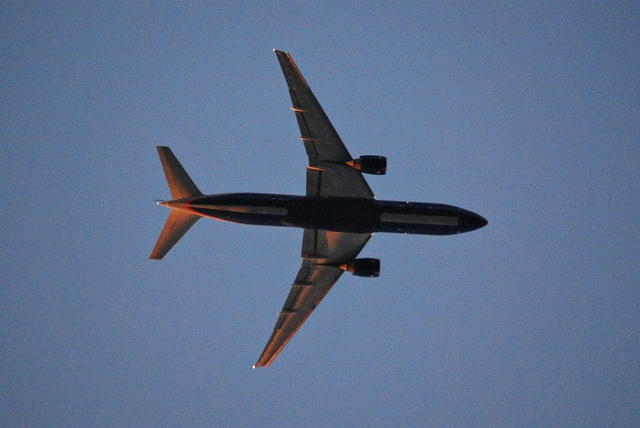Describe the objects in this image and their specific colors. I can see a airplane in gray, black, maroon, and brown tones in this image. 